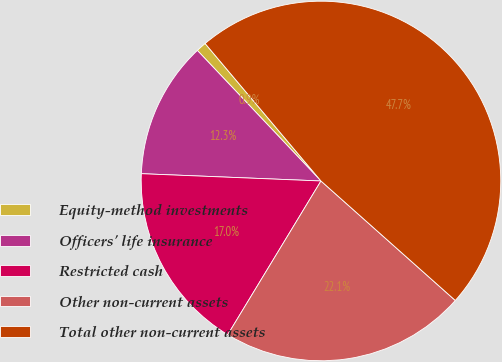<chart> <loc_0><loc_0><loc_500><loc_500><pie_chart><fcel>Equity-method investments<fcel>Officers' life insurance<fcel>Restricted cash<fcel>Other non-current assets<fcel>Total other non-current assets<nl><fcel>0.92%<fcel>12.29%<fcel>16.97%<fcel>22.11%<fcel>47.72%<nl></chart> 